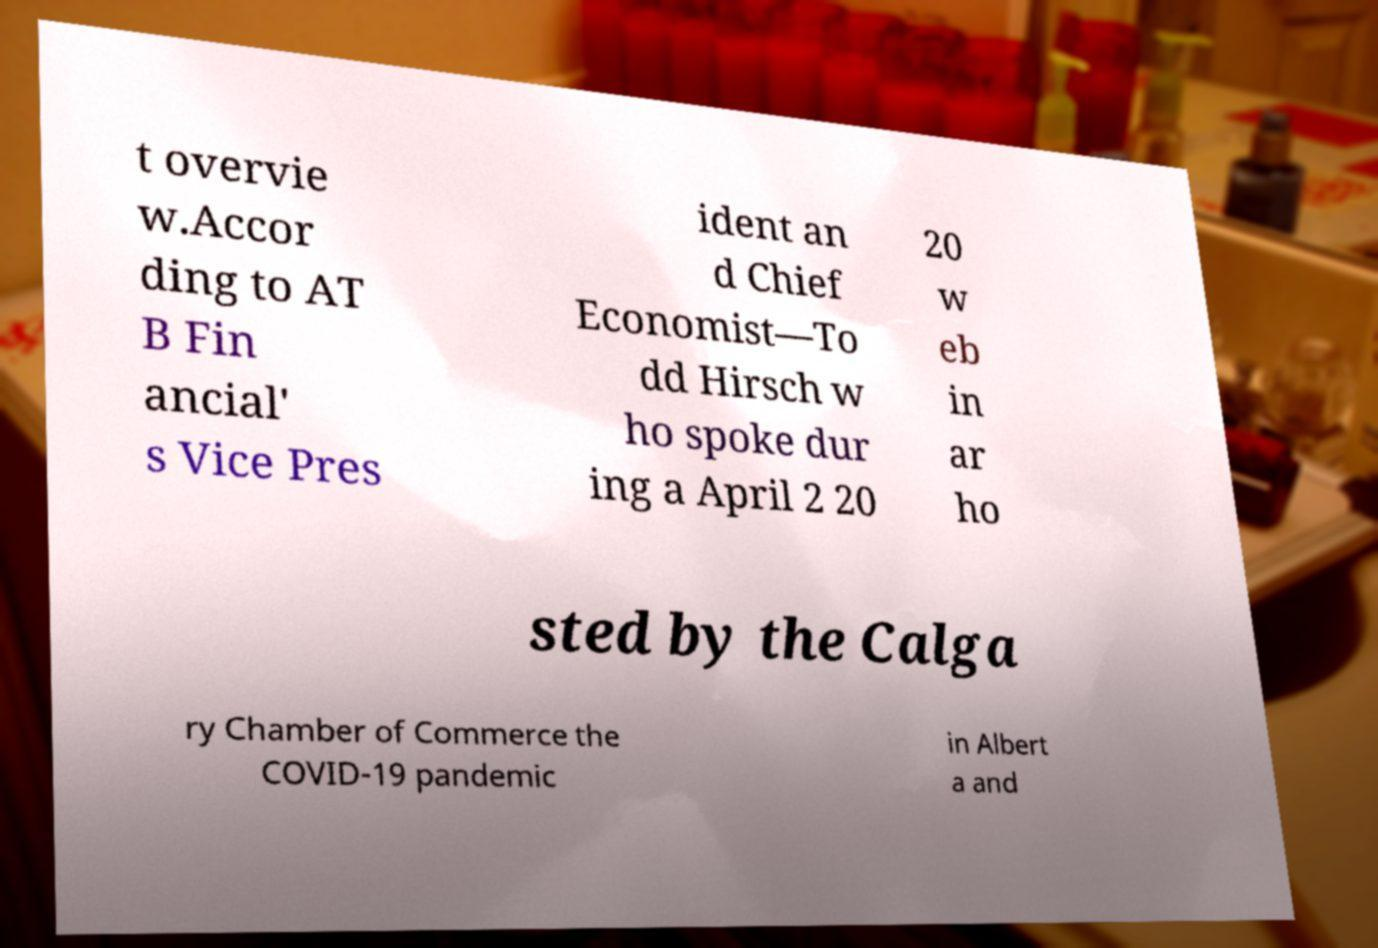I need the written content from this picture converted into text. Can you do that? t overvie w.Accor ding to AT B Fin ancial' s Vice Pres ident an d Chief Economist—To dd Hirsch w ho spoke dur ing a April 2 20 20 w eb in ar ho sted by the Calga ry Chamber of Commerce the COVID-19 pandemic in Albert a and 